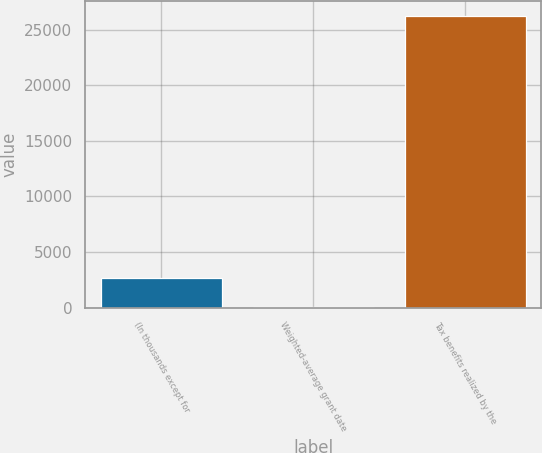Convert chart to OTSL. <chart><loc_0><loc_0><loc_500><loc_500><bar_chart><fcel>(In thousands except for<fcel>Weighted-average grant date<fcel>Tax benefits realized by the<nl><fcel>2692.03<fcel>74.48<fcel>26250<nl></chart> 